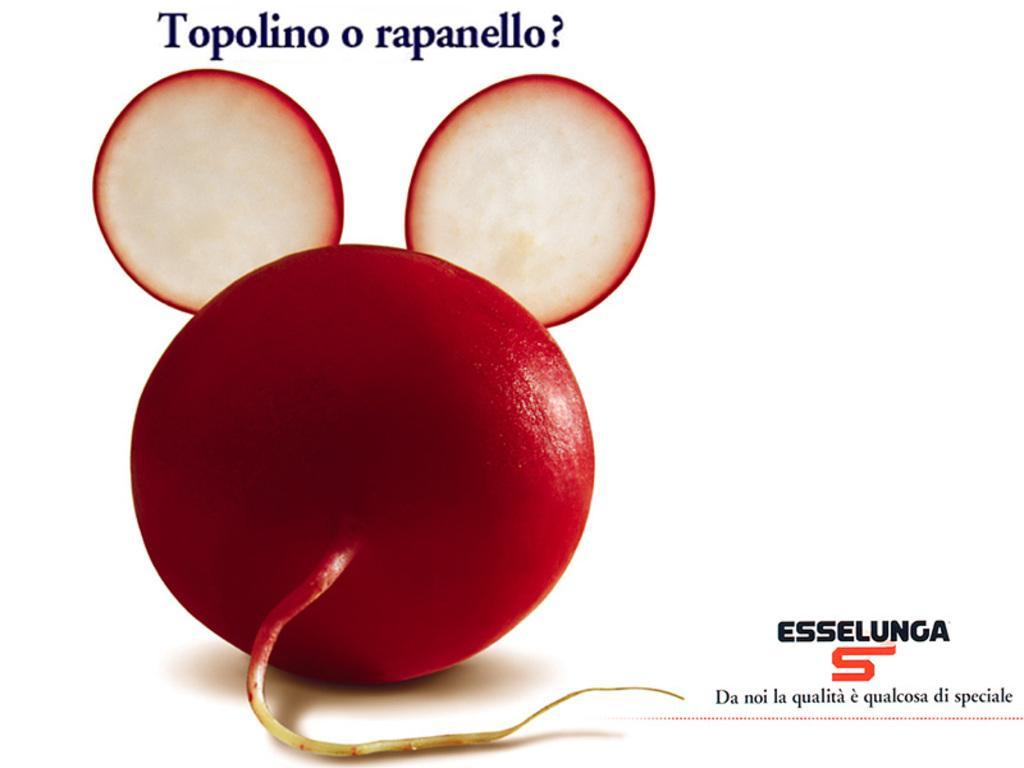Describe this image in one or two sentences. This is an edited image, we can see there is a red color object present on the left side of this image, and there is some text at the top of this image, and there is a logo with text at the bottom of this image. 